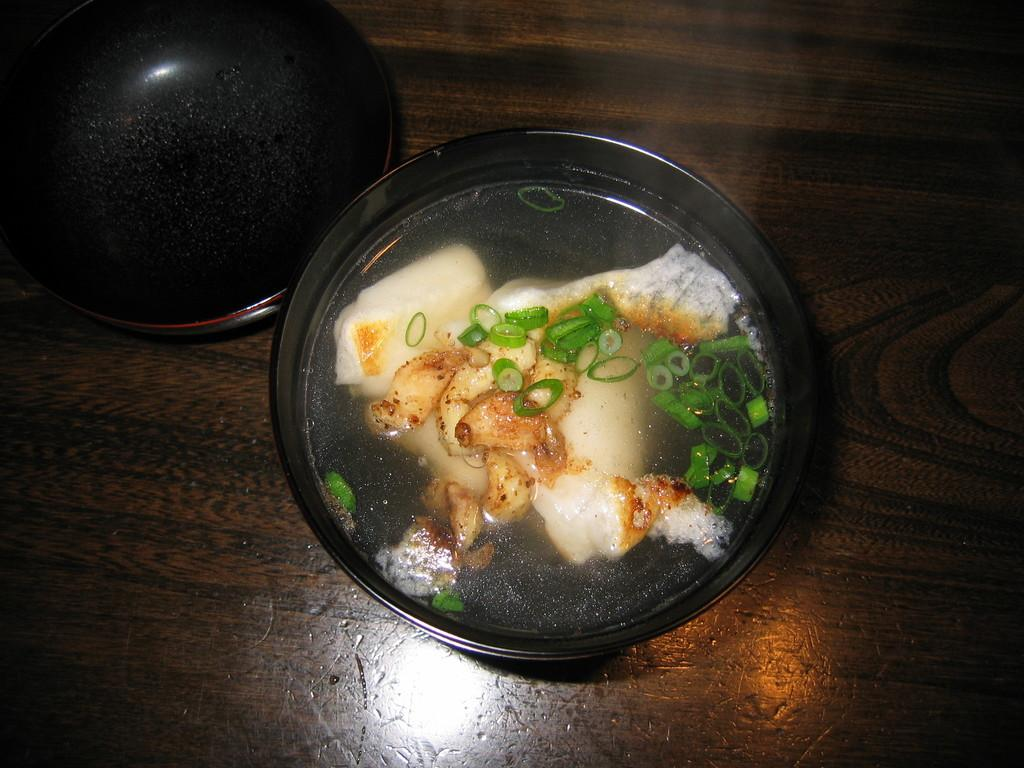What is happening in the bowl in the image? There is food preparation happening in the bowl in the image. What else can be seen in the image besides the bowl? There is an empty vessel in the image. On what surface is the empty vessel placed? The empty vessel is placed on a wooden surface. What committee is responsible for the food preparation in the image? There is no committee mentioned or implied in the image, as it only shows a bowl with food preparation and an empty vessel on a wooden surface. 